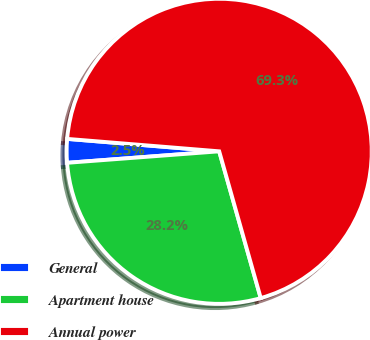Convert chart. <chart><loc_0><loc_0><loc_500><loc_500><pie_chart><fcel>General<fcel>Apartment house<fcel>Annual power<nl><fcel>2.5%<fcel>28.19%<fcel>69.31%<nl></chart> 